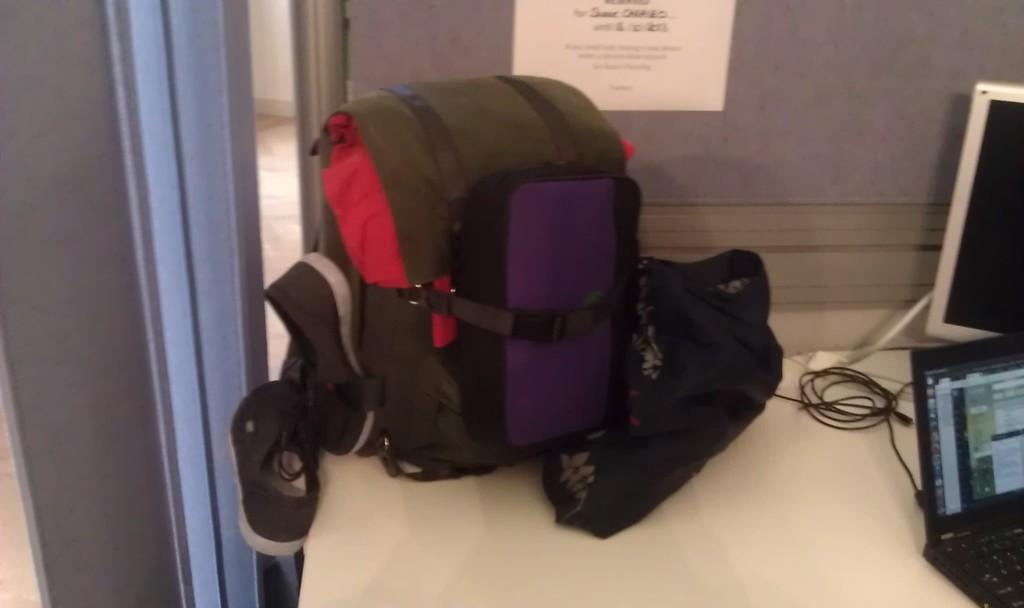What object can be seen in the image that is typically used for carrying items? There is a bag in the image that is typically used for carrying items. What electronic device is present in the image? There is a monitor and a laptop in the image. Where are all the items in the image located? All items are present on a table in the image. What can be seen on the wall in the image? There is a paper stuck on the wall in the image. What is the name of the airplane visible in the image? There is no airplane visible in the image. What type of ornament is hanging from the ceiling in the image? There is no ornament hanging from the ceiling in the image. 